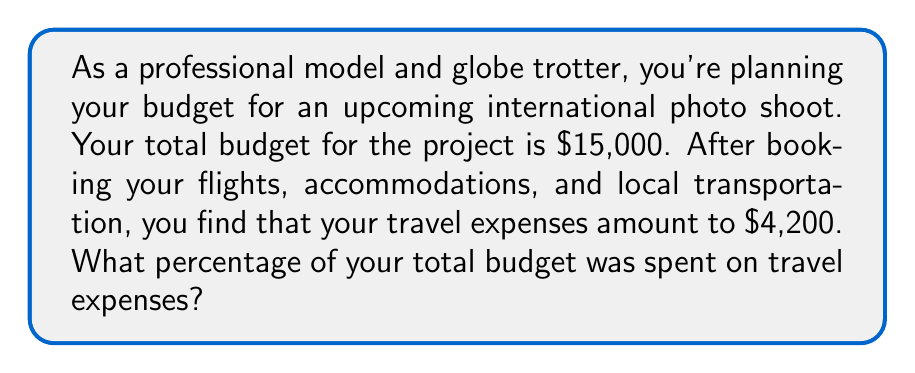Provide a solution to this math problem. To calculate the percentage of the budget spent on travel expenses, we need to follow these steps:

1. Identify the total budget and the amount spent on travel:
   Total budget: $15,000
   Travel expenses: $4,200

2. Set up the percentage formula:
   $$\text{Percentage} = \frac{\text{Part}}{\text{Whole}} \times 100\%$$

3. Plug in the values:
   $$\text{Percentage} = \frac{\text{Travel expenses}}{\text{Total budget}} \times 100\%$$
   $$\text{Percentage} = \frac{4200}{15000} \times 100\%$$

4. Simplify the fraction:
   $$\frac{4200}{15000} = \frac{28}{100} = 0.28$$

5. Multiply by 100% to get the final percentage:
   $$0.28 \times 100\% = 28\%$$

Therefore, 28% of the total budget was spent on travel expenses.
Answer: 28% 